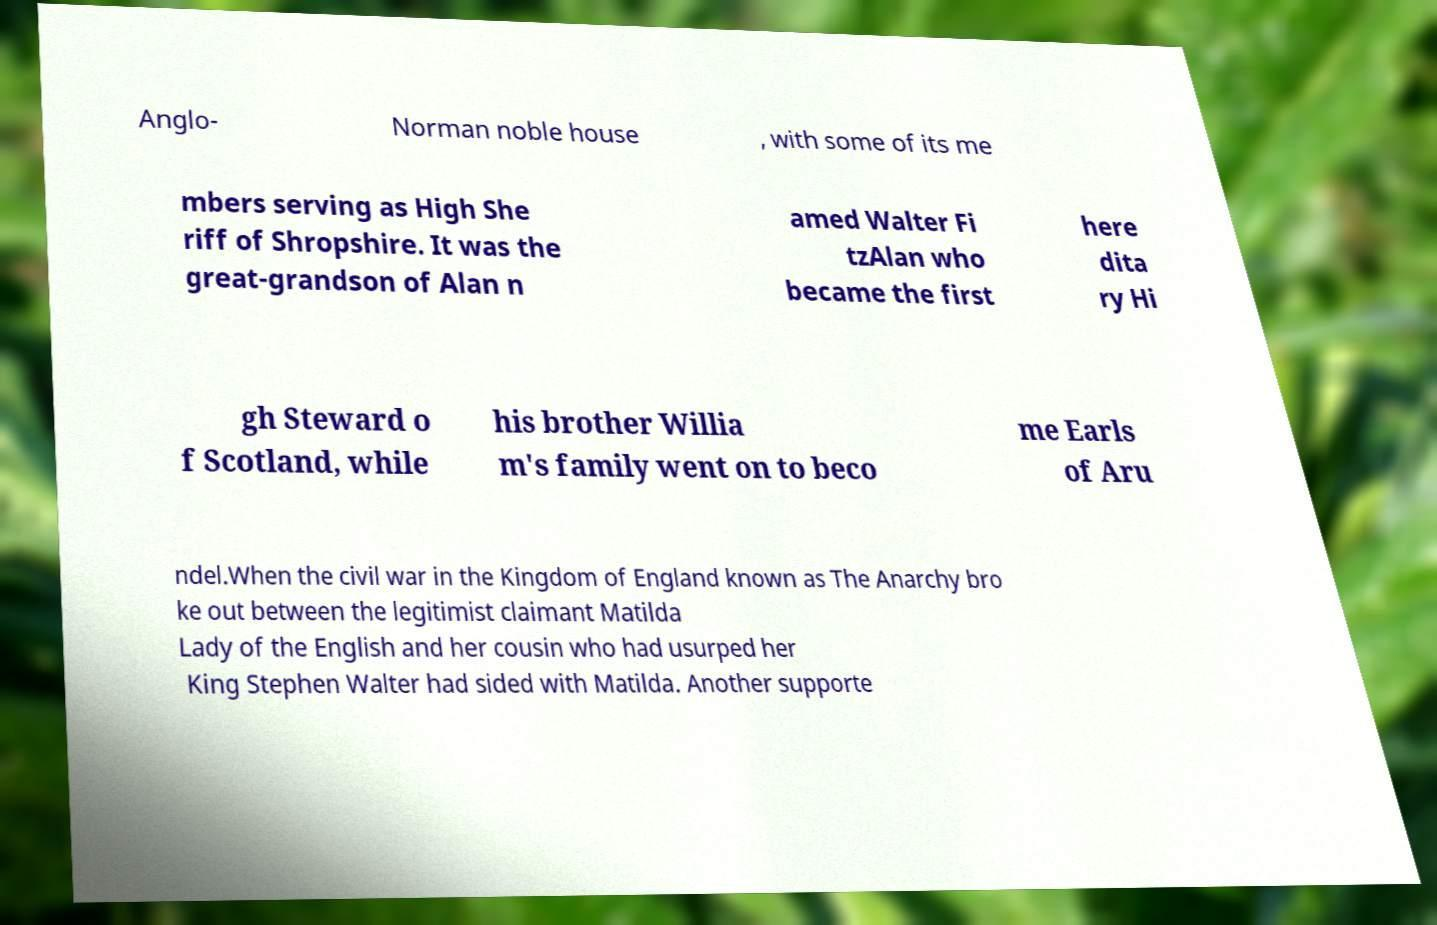Can you accurately transcribe the text from the provided image for me? Anglo- Norman noble house , with some of its me mbers serving as High She riff of Shropshire. It was the great-grandson of Alan n amed Walter Fi tzAlan who became the first here dita ry Hi gh Steward o f Scotland, while his brother Willia m's family went on to beco me Earls of Aru ndel.When the civil war in the Kingdom of England known as The Anarchy bro ke out between the legitimist claimant Matilda Lady of the English and her cousin who had usurped her King Stephen Walter had sided with Matilda. Another supporte 